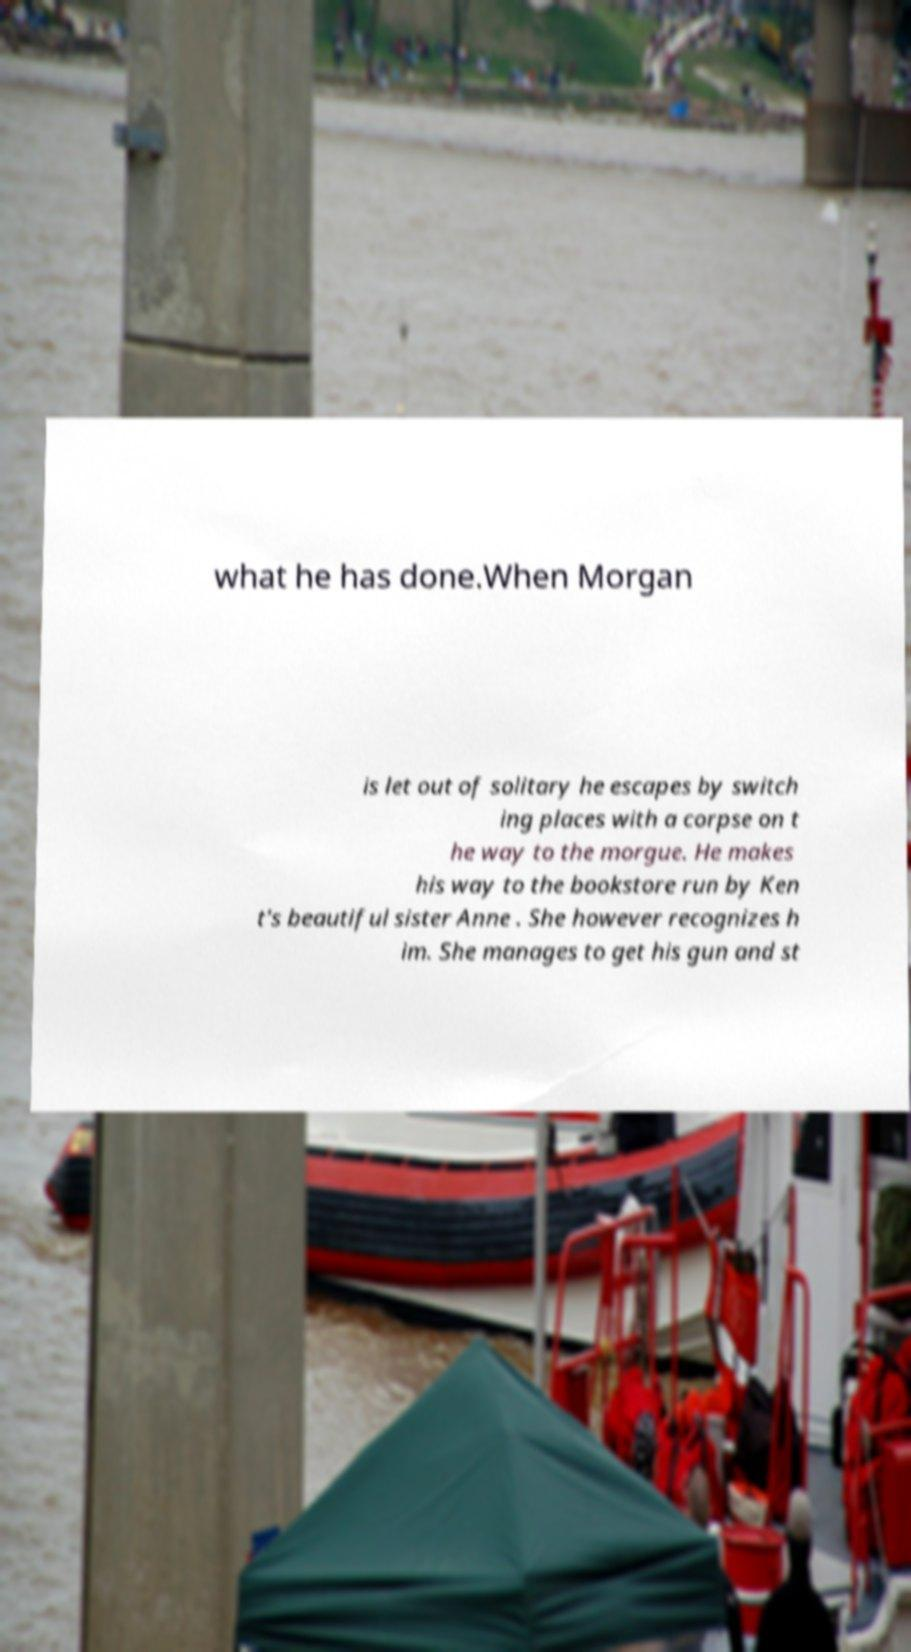There's text embedded in this image that I need extracted. Can you transcribe it verbatim? what he has done.When Morgan is let out of solitary he escapes by switch ing places with a corpse on t he way to the morgue. He makes his way to the bookstore run by Ken t's beautiful sister Anne . She however recognizes h im. She manages to get his gun and st 